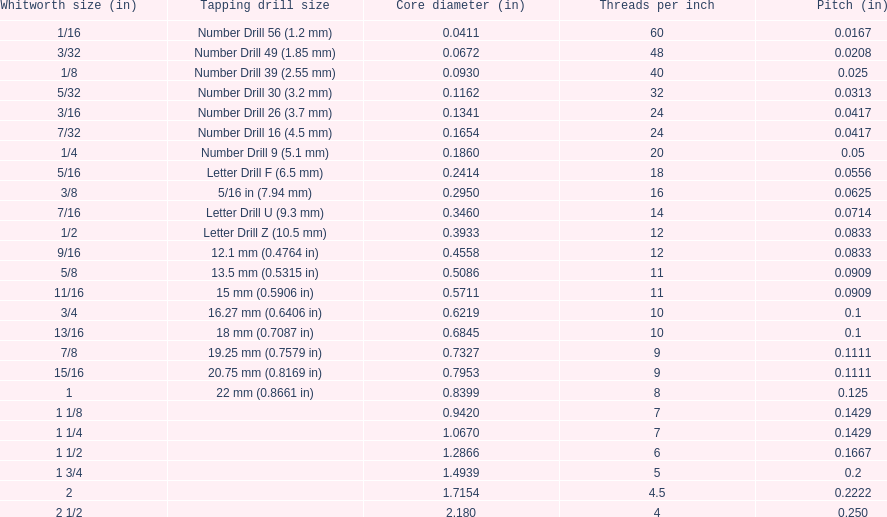What is the top amount of threads per inch? 60. 